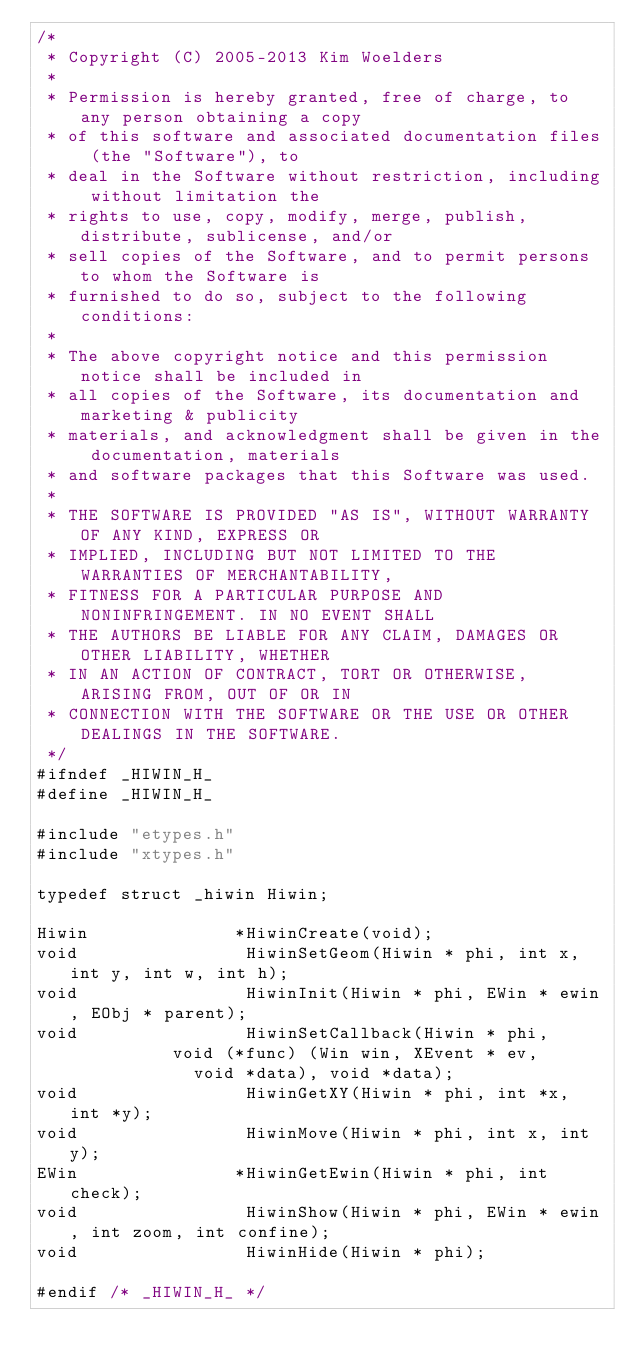<code> <loc_0><loc_0><loc_500><loc_500><_C_>/*
 * Copyright (C) 2005-2013 Kim Woelders
 *
 * Permission is hereby granted, free of charge, to any person obtaining a copy
 * of this software and associated documentation files (the "Software"), to
 * deal in the Software without restriction, including without limitation the
 * rights to use, copy, modify, merge, publish, distribute, sublicense, and/or
 * sell copies of the Software, and to permit persons to whom the Software is
 * furnished to do so, subject to the following conditions:
 *
 * The above copyright notice and this permission notice shall be included in
 * all copies of the Software, its documentation and marketing & publicity
 * materials, and acknowledgment shall be given in the documentation, materials
 * and software packages that this Software was used.
 *
 * THE SOFTWARE IS PROVIDED "AS IS", WITHOUT WARRANTY OF ANY KIND, EXPRESS OR
 * IMPLIED, INCLUDING BUT NOT LIMITED TO THE WARRANTIES OF MERCHANTABILITY,
 * FITNESS FOR A PARTICULAR PURPOSE AND NONINFRINGEMENT. IN NO EVENT SHALL
 * THE AUTHORS BE LIABLE FOR ANY CLAIM, DAMAGES OR OTHER LIABILITY, WHETHER
 * IN AN ACTION OF CONTRACT, TORT OR OTHERWISE, ARISING FROM, OUT OF OR IN
 * CONNECTION WITH THE SOFTWARE OR THE USE OR OTHER DEALINGS IN THE SOFTWARE.
 */
#ifndef _HIWIN_H_
#define _HIWIN_H_

#include "etypes.h"
#include "xtypes.h"

typedef struct _hiwin Hiwin;

Hiwin              *HiwinCreate(void);
void                HiwinSetGeom(Hiwin * phi, int x, int y, int w, int h);
void                HiwinInit(Hiwin * phi, EWin * ewin, EObj * parent);
void                HiwinSetCallback(Hiwin * phi,
				     void (*func) (Win win, XEvent * ev,
						   void *data), void *data);
void                HiwinGetXY(Hiwin * phi, int *x, int *y);
void                HiwinMove(Hiwin * phi, int x, int y);
EWin               *HiwinGetEwin(Hiwin * phi, int check);
void                HiwinShow(Hiwin * phi, EWin * ewin, int zoom, int confine);
void                HiwinHide(Hiwin * phi);

#endif /* _HIWIN_H_ */
</code> 